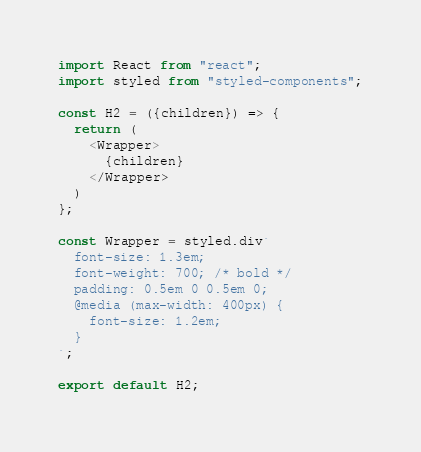Convert code to text. <code><loc_0><loc_0><loc_500><loc_500><_JavaScript_>import React from "react";
import styled from "styled-components";

const H2 = ({children}) => {
  return (
    <Wrapper>
      {children}
    </Wrapper>
  )
};

const Wrapper = styled.div`
  font-size: 1.3em;
  font-weight: 700; /* bold */
  padding: 0.5em 0 0.5em 0;
  @media (max-width: 400px) {
    font-size: 1.2em;
  }
`;

export default H2;</code> 